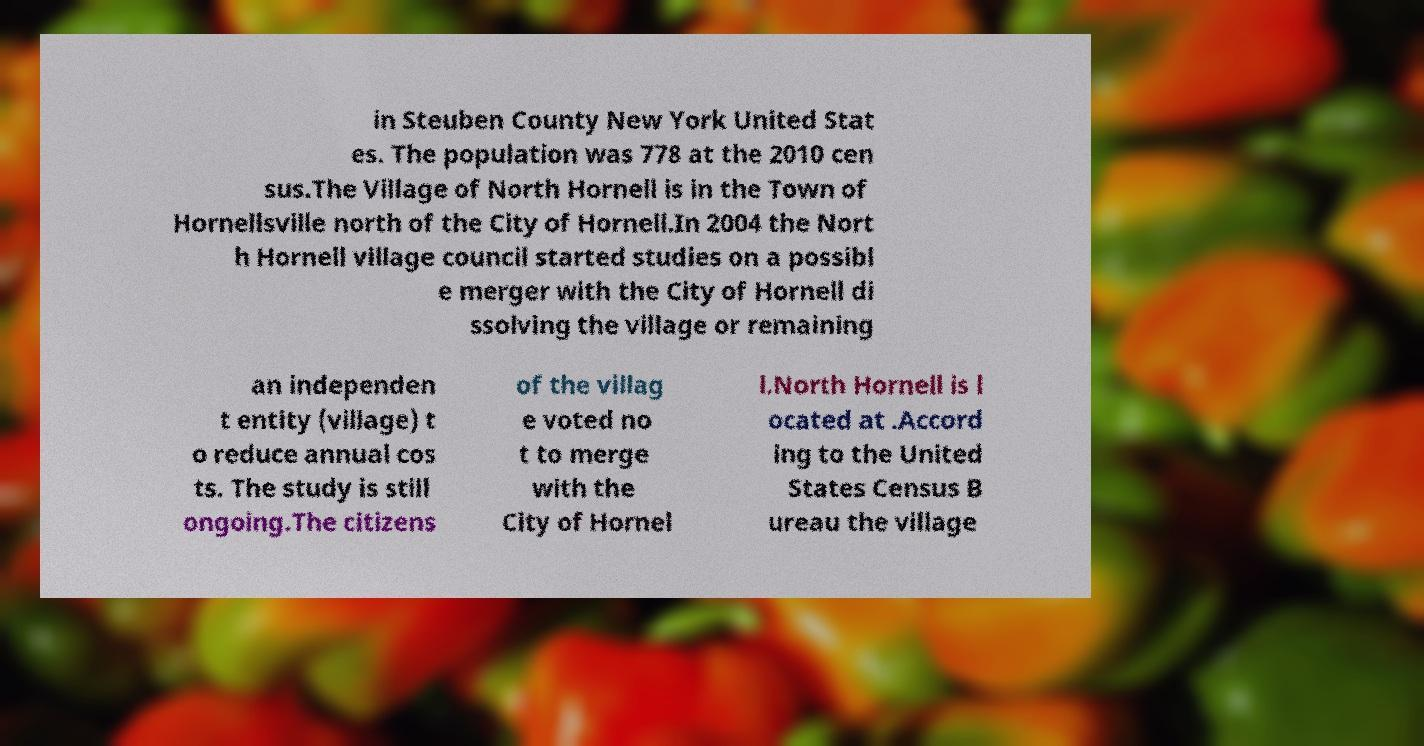Please read and relay the text visible in this image. What does it say? in Steuben County New York United Stat es. The population was 778 at the 2010 cen sus.The Village of North Hornell is in the Town of Hornellsville north of the City of Hornell.In 2004 the Nort h Hornell village council started studies on a possibl e merger with the City of Hornell di ssolving the village or remaining an independen t entity (village) t o reduce annual cos ts. The study is still ongoing.The citizens of the villag e voted no t to merge with the City of Hornel l.North Hornell is l ocated at .Accord ing to the United States Census B ureau the village 